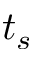<formula> <loc_0><loc_0><loc_500><loc_500>t _ { s }</formula> 